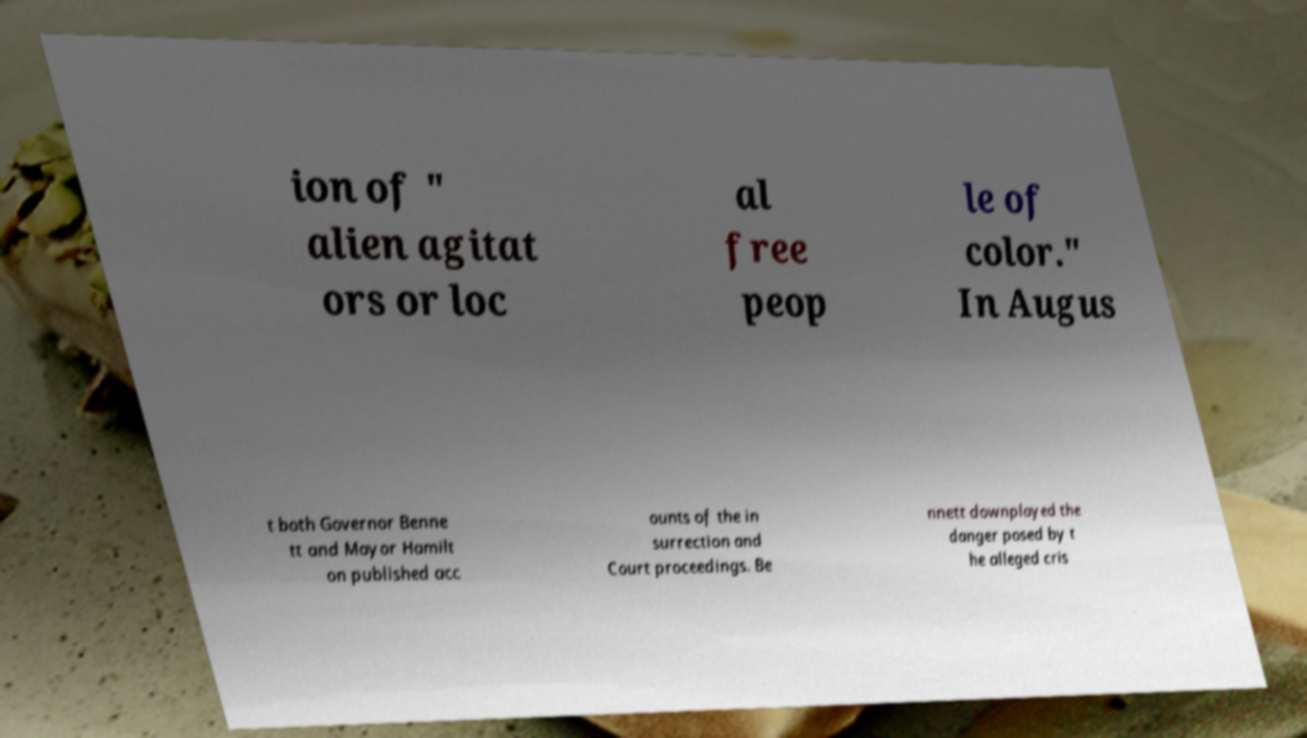Please read and relay the text visible in this image. What does it say? ion of " alien agitat ors or loc al free peop le of color." In Augus t both Governor Benne tt and Mayor Hamilt on published acc ounts of the in surrection and Court proceedings. Be nnett downplayed the danger posed by t he alleged cris 